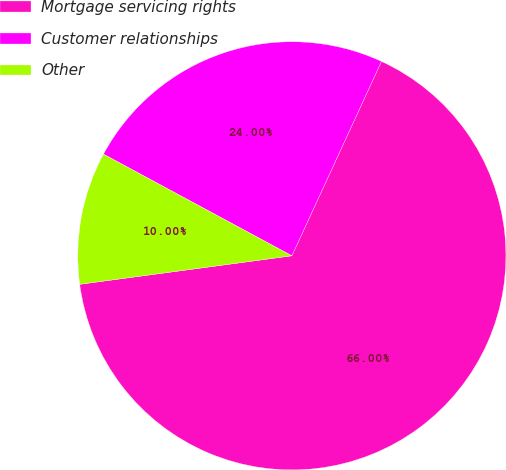Convert chart to OTSL. <chart><loc_0><loc_0><loc_500><loc_500><pie_chart><fcel>Mortgage servicing rights<fcel>Customer relationships<fcel>Other<nl><fcel>66.0%<fcel>24.0%<fcel>10.0%<nl></chart> 